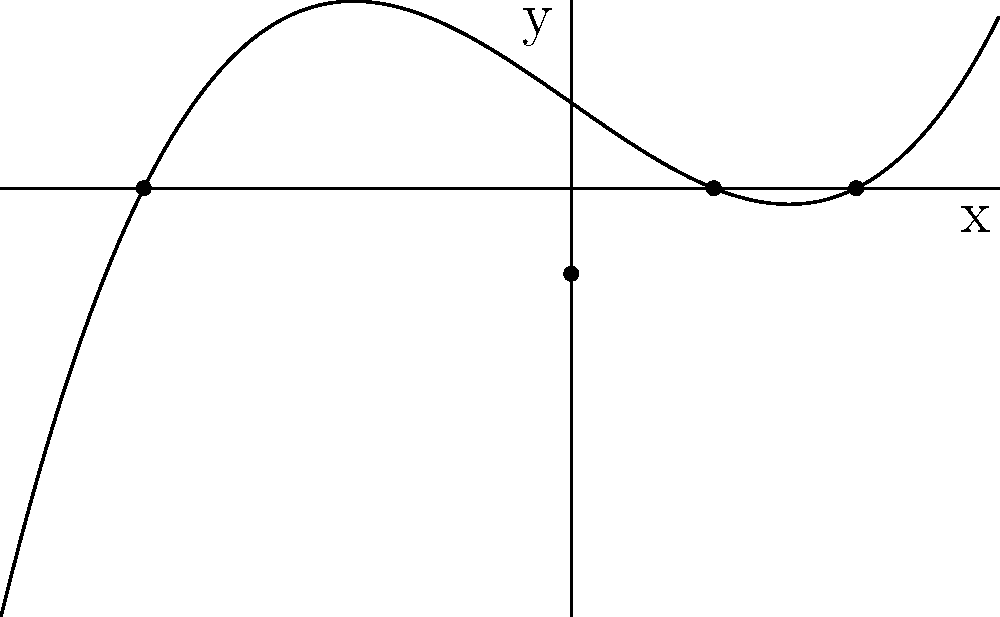Sketch the graph of the polynomial function $f(x) = 0.1(x+3)(x-1)(x-2)$. Identify the x-intercepts, y-intercept, and the behavior of the function as $x$ approaches positive and negative infinity. Let's approach this step-by-step:

1) First, let's identify the zeros (x-intercepts) of the function:
   - The factors are $(x+3)$, $(x-1)$, and $(x-2)$
   - Setting each factor to zero: $x = -3$, $x = 1$, and $x = 2$
   - These are the x-intercepts

2) To find the y-intercept, let $x = 0$:
   $f(0) = 0.1(0+3)(0-1)(0-2) = 0.1(3)(-1)(-2) = 0.6$
   So the y-intercept is $(0, 0.6)$

3) The leading coefficient is positive (0.1), and the degree of the polynomial is odd (3), so:
   - As $x \to +\infty$, $f(x) \to +\infty$
   - As $x \to -\infty$, $f(x) \to -\infty$

4) Sketching the graph:
   - Plot the x-intercepts: $(-3,0)$, $(1,0)$, and $(2,0)$
   - Plot the y-intercept: $(0,0.6)$
   - The function will pass through these points
   - The graph will start in the third quadrant, pass through $(-3,0)$, rise to $(0,0.6)$, then fall through $(1,0)$ and $(2,0)$, and finally rise again in the first quadrant

5) The turning points will be between the zeros, but their exact locations would require calculus to determine precisely.
Answer: X-intercepts: $-3$, $1$, $2$; Y-intercept: $(0,0.6)$; As $x \to +\infty$, $f(x) \to +\infty$; As $x \to -\infty$, $f(x) \to -\infty$ 